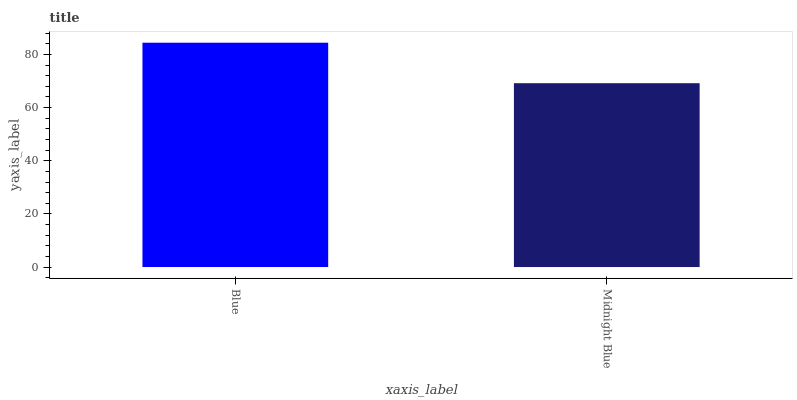Is Midnight Blue the minimum?
Answer yes or no. Yes. Is Blue the maximum?
Answer yes or no. Yes. Is Midnight Blue the maximum?
Answer yes or no. No. Is Blue greater than Midnight Blue?
Answer yes or no. Yes. Is Midnight Blue less than Blue?
Answer yes or no. Yes. Is Midnight Blue greater than Blue?
Answer yes or no. No. Is Blue less than Midnight Blue?
Answer yes or no. No. Is Blue the high median?
Answer yes or no. Yes. Is Midnight Blue the low median?
Answer yes or no. Yes. Is Midnight Blue the high median?
Answer yes or no. No. Is Blue the low median?
Answer yes or no. No. 